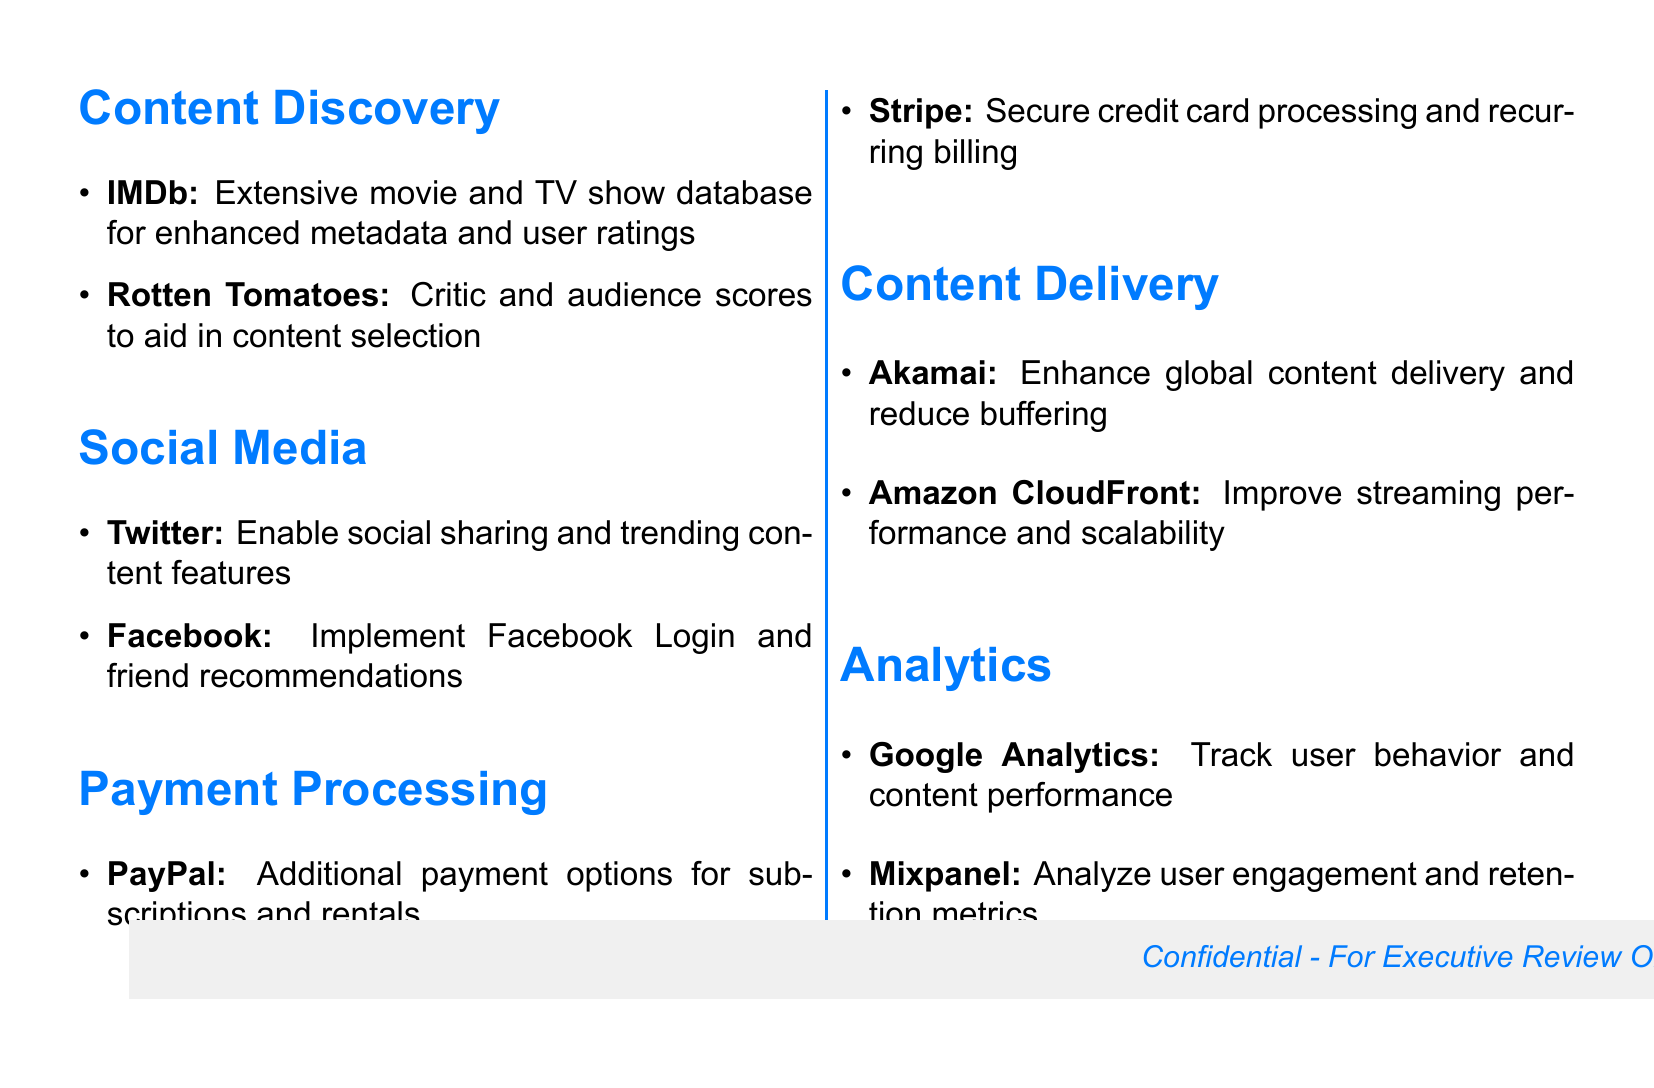What service is suggested for enhanced metadata? The document mentions integrating IMDb's extensive movie and TV show database for enhanced metadata and user ratings.
Answer: IMDb What service provides critic and audience scores? The document states that Rotten Tomatoes is incorporated to aid in content selection with critic and audience scores.
Answer: Rotten Tomatoes Which social media service is included for sharing features? Twitter is mentioned in the document as enabling social sharing and trending content features.
Answer: Twitter What payment processing service offers secure credit card processing? The document indicates that Stripe is implemented for secure credit card processing and recurring billing.
Answer: Stripe What content delivery service is suggested for reducing buffering? Akamai is recommended in the document to enhance global content delivery and reduce buffering.
Answer: Akamai Which service is used for tracking user behavior? Google Analytics is listed for tracking user behavior and content performance in the document.
Answer: Google Analytics How many integrations are listed under the Payment Processing section? The document specifies two integrations under the Payment Processing section: PayPal and Stripe.
Answer: Two What is the purpose of integrating Facebook according to the document? The document states that Facebook is integrated to implement Facebook Login and friend recommendations.
Answer: Facebook Login Which service is recommended for improving streaming performance? The document mentions Amazon CloudFront to improve streaming performance and scalability.
Answer: Amazon CloudFront 